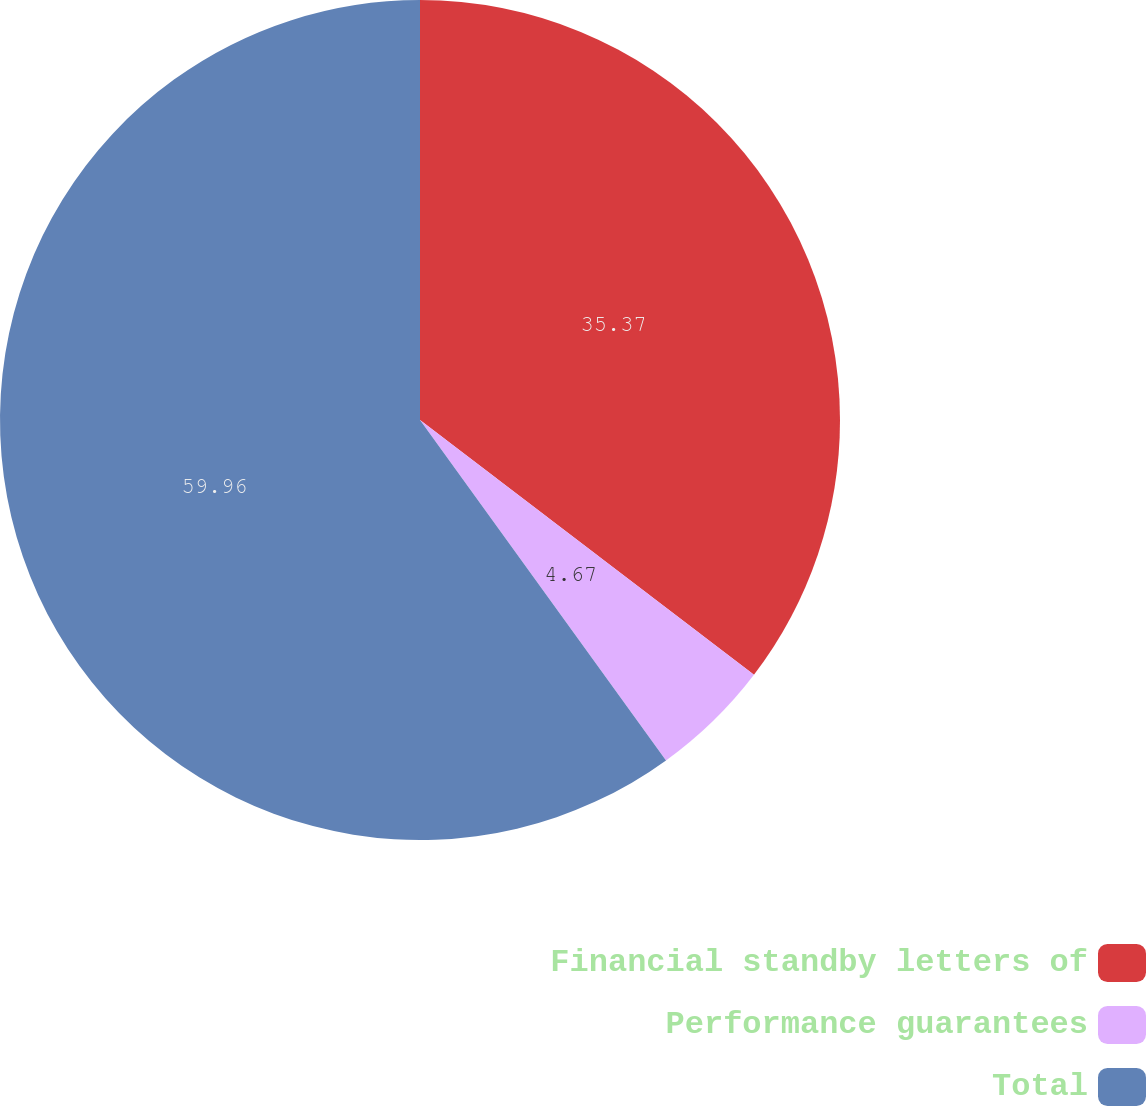Convert chart. <chart><loc_0><loc_0><loc_500><loc_500><pie_chart><fcel>Financial standby letters of<fcel>Performance guarantees<fcel>Total<nl><fcel>35.37%<fcel>4.67%<fcel>59.96%<nl></chart> 